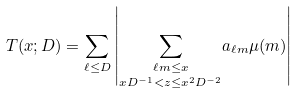Convert formula to latex. <formula><loc_0><loc_0><loc_500><loc_500>T ( x ; D ) = \sum _ { \ell \leq D } \left | \underset { x D ^ { - 1 } < z \leq x ^ { 2 } D ^ { - 2 } } { \sum _ { \ell m \leq x } } a _ { \ell m } \mu ( m ) \right |</formula> 